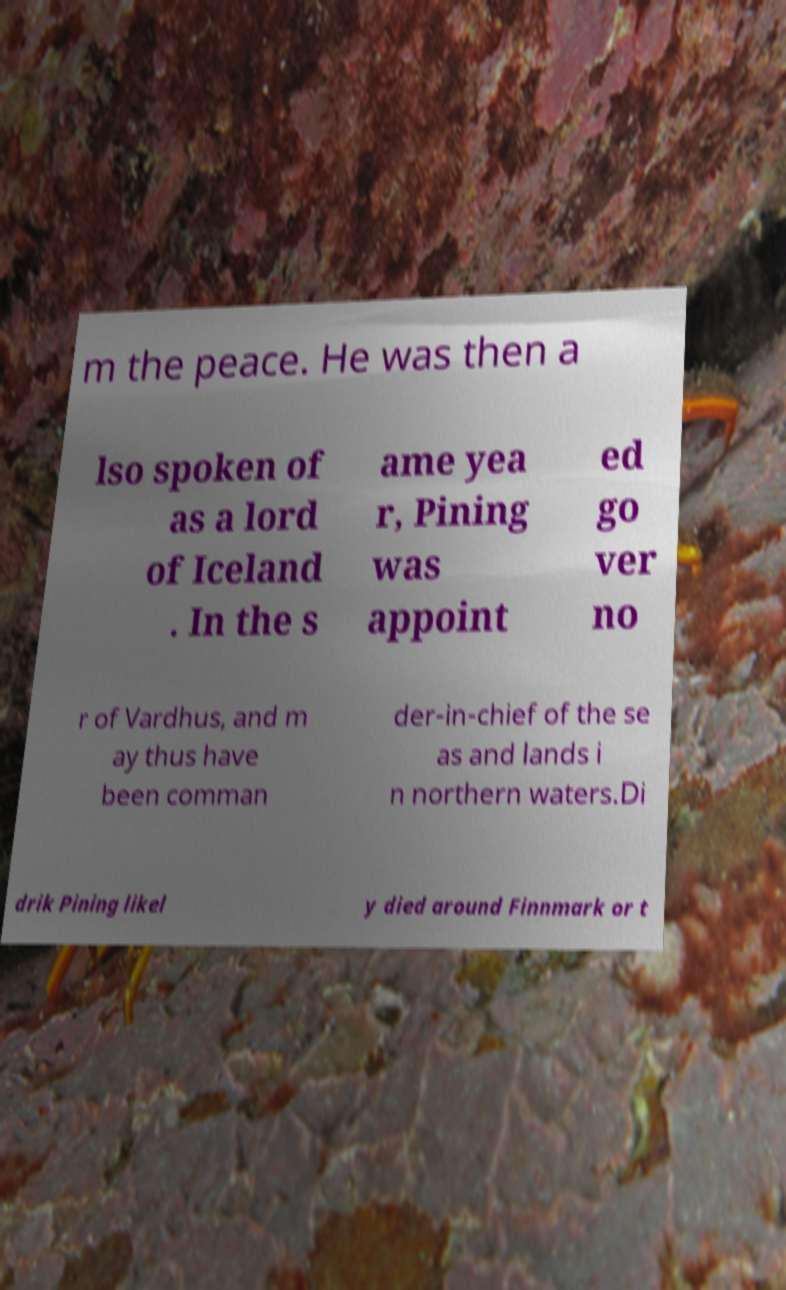There's text embedded in this image that I need extracted. Can you transcribe it verbatim? m the peace. He was then a lso spoken of as a lord of Iceland . In the s ame yea r, Pining was appoint ed go ver no r of Vardhus, and m ay thus have been comman der-in-chief of the se as and lands i n northern waters.Di drik Pining likel y died around Finnmark or t 